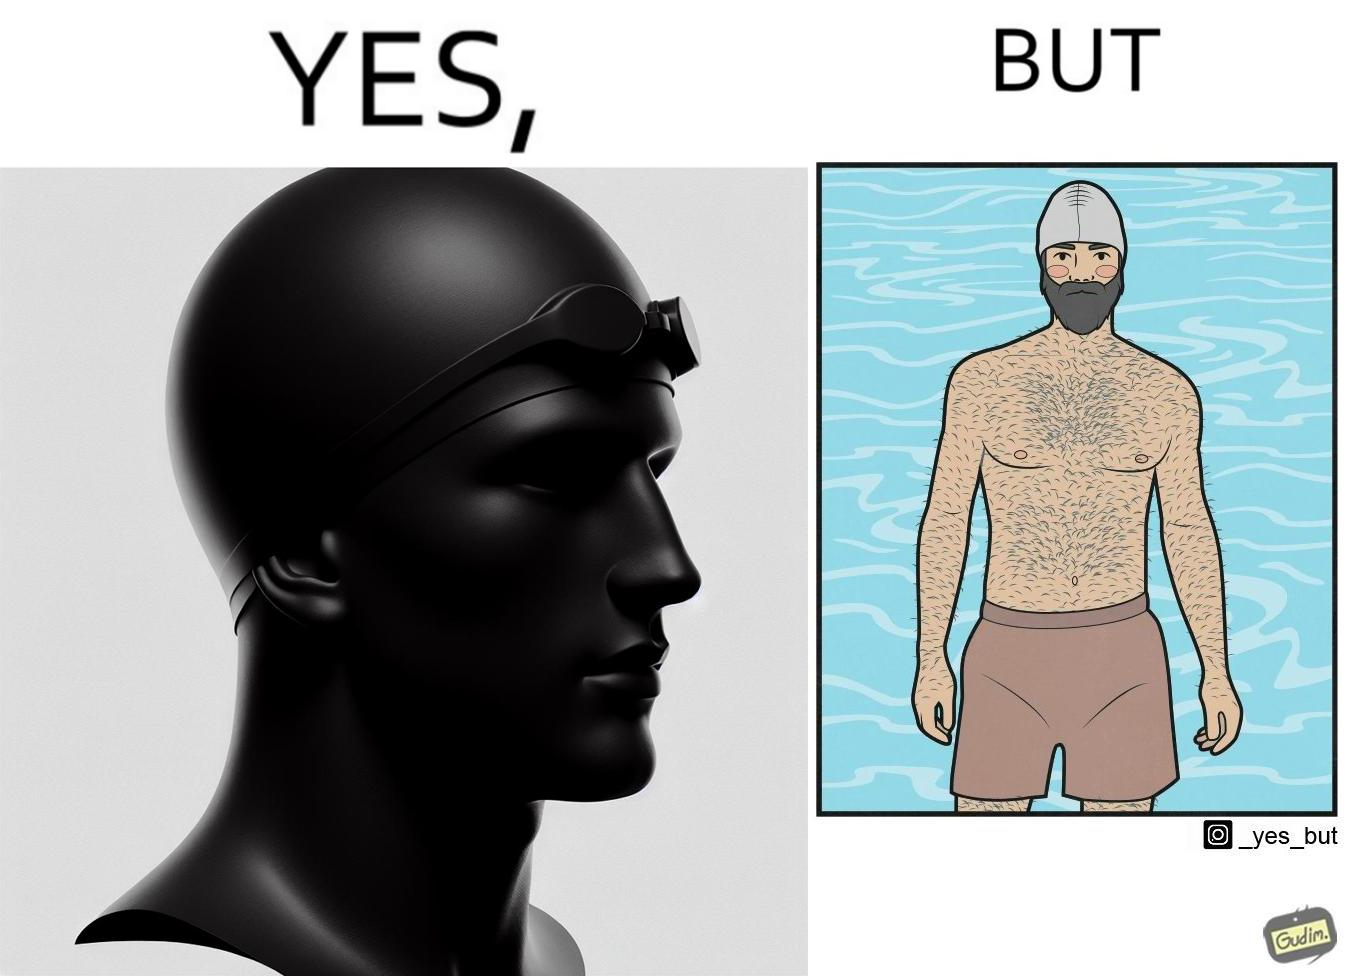Why is this image considered satirical? The man is wearing a swimming cap to protect his head's hair but on the other side he is not concerned over the hair all over his body and is nowhere covering them 